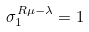<formula> <loc_0><loc_0><loc_500><loc_500>\sigma _ { 1 } ^ { R \mu - \lambda } = 1</formula> 